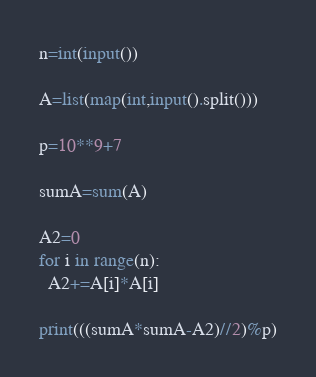<code> <loc_0><loc_0><loc_500><loc_500><_Python_>n=int(input())

A=list(map(int,input().split()))

p=10**9+7

sumA=sum(A)

A2=0
for i in range(n):
  A2+=A[i]*A[i]

print(((sumA*sumA-A2)//2)%p)
</code> 